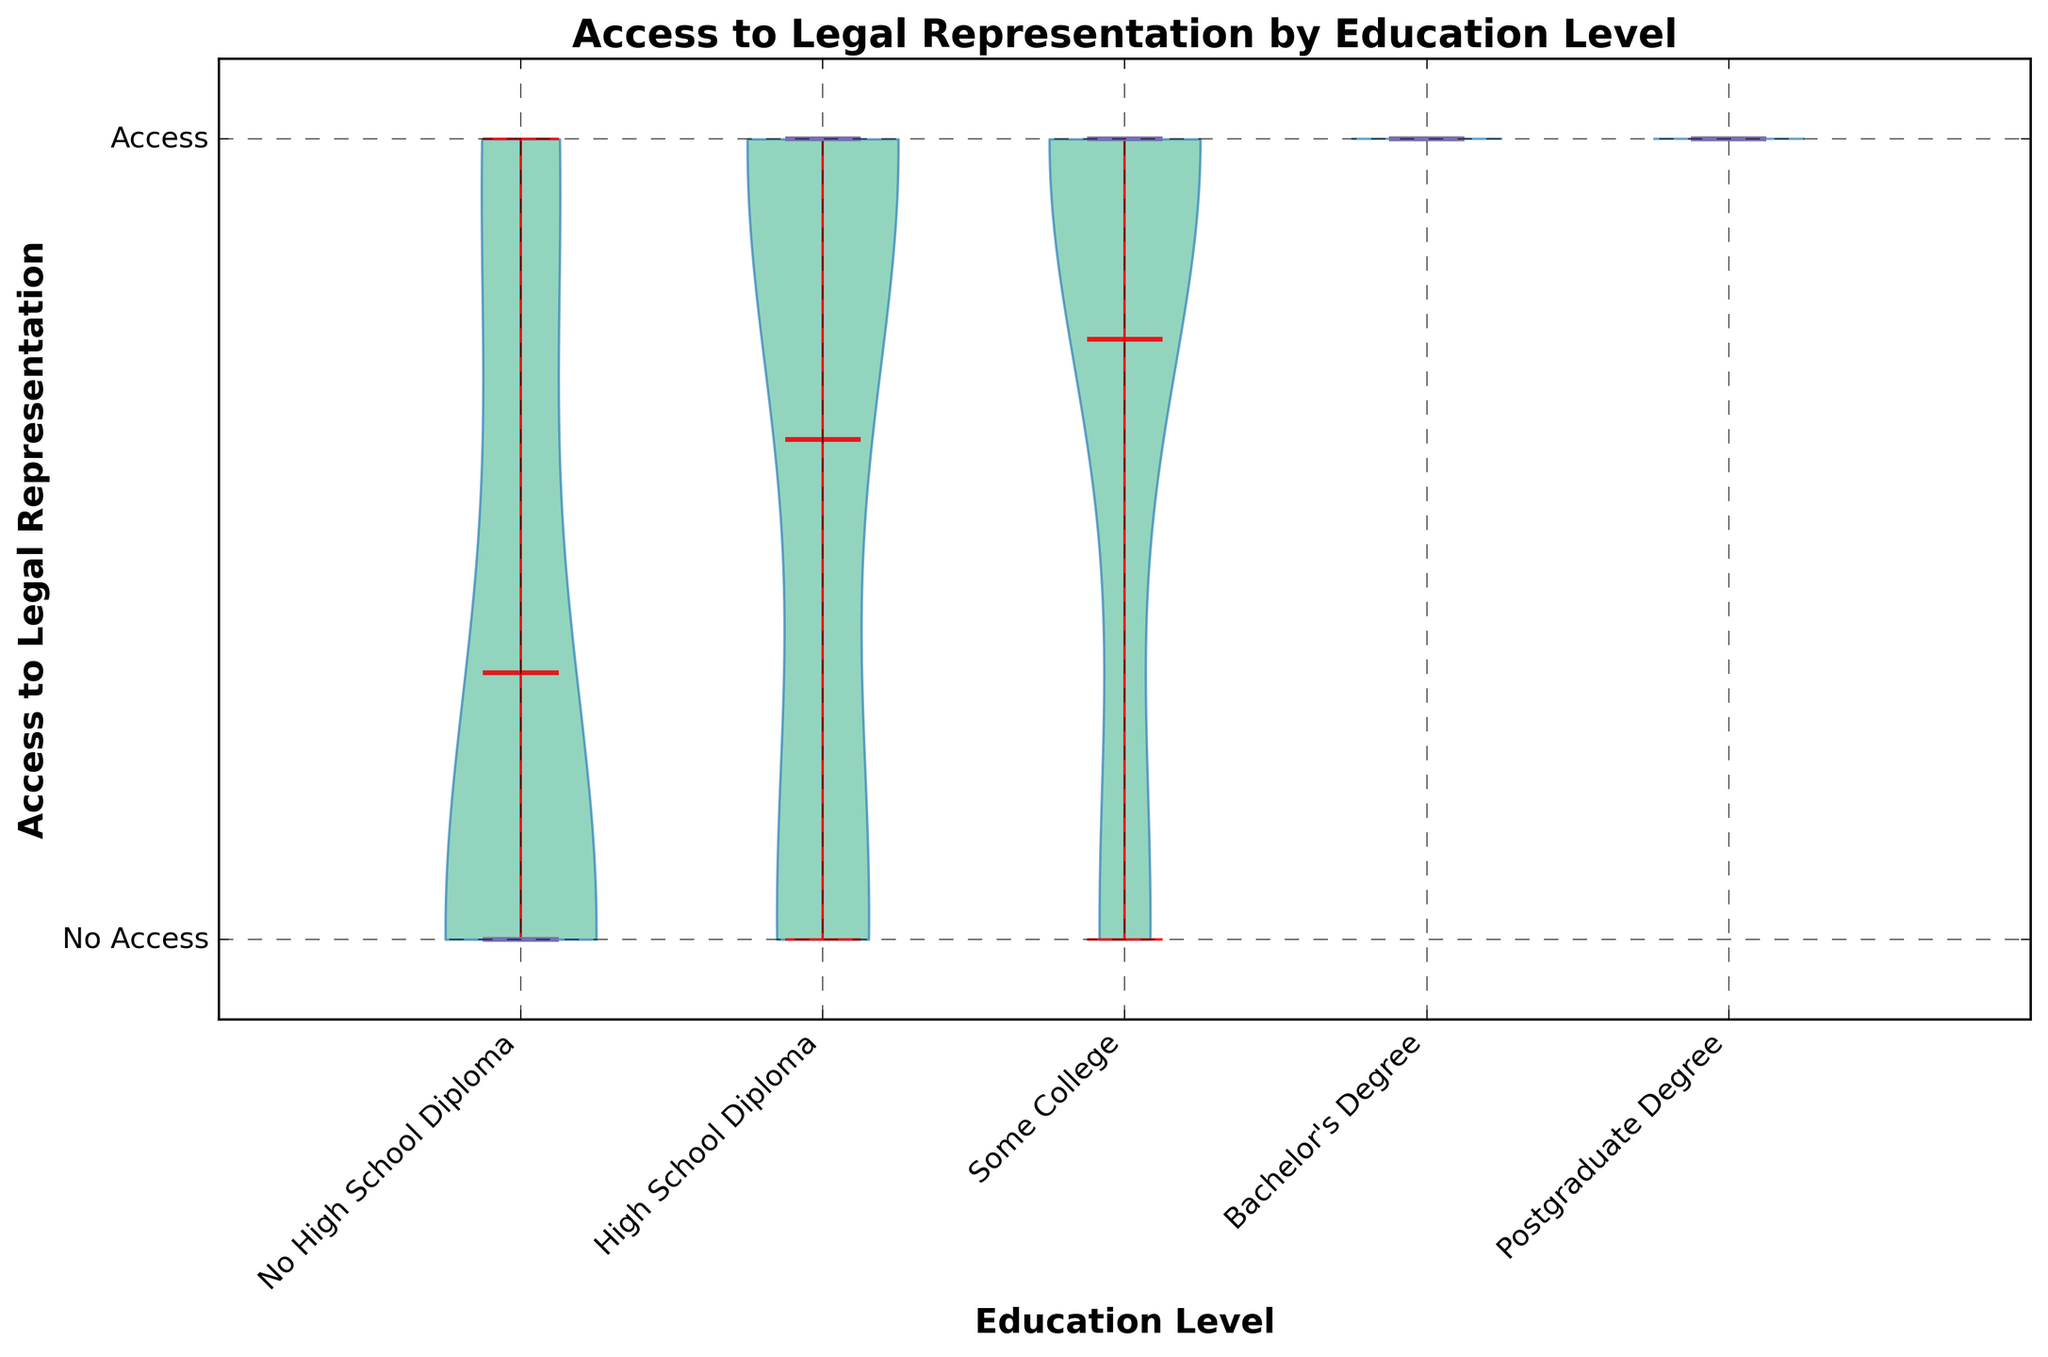How many distinct education levels are displayed in the violin chart? There are five distinct education levels shown on the x-axis: 'No High School Diploma', 'High School Diploma', 'Some College', "Bachelor's Degree", and 'Postgraduate Degree'.
Answer: Five What is the y-axis range of the chart? The y-axis range of the chart extends from -0.1 to 1.1, encompassing values for both "No Access" and "Access" to legal representation.
Answer: -0.1 to 1.1 Which education level has the highest median access to legal representation? The median line is indicated in a specific color (purple). By examining the medians, "Bachelor's Degree" and "Postgraduate Degree" groups have the highest, with median values equal to 1.
Answer: "Bachelor's Degree" and "Postgraduate Degree" Within which education level is the variance in access to legal representation the lowest? Variance can be visually assessed by the width of the violin plot at various points; the narrower the plot, the lower the variance. "Postgraduate Degree" has the narrowest spread, indicating the lowest variance.
Answer: Postgraduate Degree Compare the mean access to legal representation for individuals with "Some College" education level to those with a "Bachelor's Degree." Which is higher? The means are represented by the horizontal lines in red. The mean for "Bachelor's Degree" is higher when compared to "Some College".
Answer: Bachelor's Degree Is there a visible pattern between the level of education and access to legal representation? The median and mean access to legal representation tend to increase with higher levels of education, indicating a positive correlation between education level and access to legal representation.
Answer: Yes Describe the distribution of access to legal representation for individuals with no high school diploma. The distribution for 'No High School Diploma' is more spread out, with less overall access indicated by a larger portion of the violin at the 'No Access' level (0) compared to the 'Access' level (1).
Answer: More spread towards 'No Access' For which education level is the mean value of access to legal representation closest to the median value? The closeness of the mean (red line) to the median (purple line) can be assessed visually. For "Some College", the mean and median values are very close, both around 0.75.
Answer: Some College What does the color of the median line indicate, and where is it located in the plot for each education level? The purple line represents the median value for access to legal representation, located roughly at the middle of each violin. For "No High School Diploma", it's nearer to the lower half; for higher education levels, it's nearer or equal to the 'Access' level (1).
Answer: Median values How is the overall access to legal representation trend depicted across different education levels in the chart? The trend shows that access to legal representation increases with higher education levels, as evidenced by the increasing position of the median and mean values and the shape of the violins becoming more concentrated towards the 'Access' level.
Answer: Increases with education level 